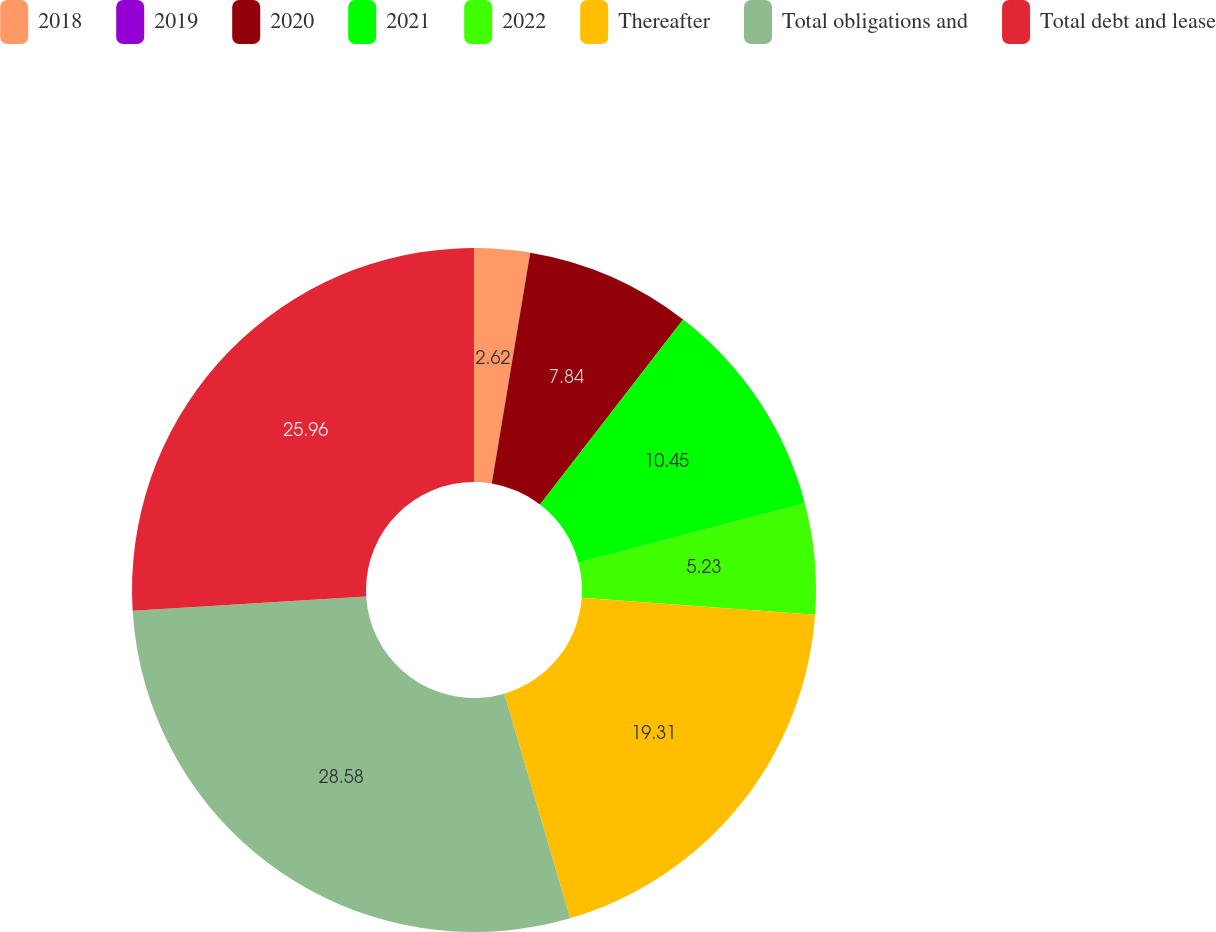Convert chart. <chart><loc_0><loc_0><loc_500><loc_500><pie_chart><fcel>2018<fcel>2019<fcel>2020<fcel>2021<fcel>2022<fcel>Thereafter<fcel>Total obligations and<fcel>Total debt and lease<nl><fcel>2.62%<fcel>0.01%<fcel>7.84%<fcel>10.45%<fcel>5.23%<fcel>19.31%<fcel>28.57%<fcel>25.96%<nl></chart> 